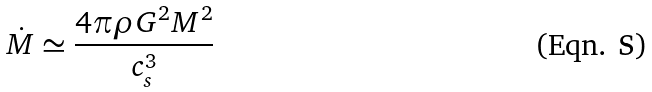Convert formula to latex. <formula><loc_0><loc_0><loc_500><loc_500>\dot { M } \simeq \frac { 4 \pi \rho G ^ { 2 } M ^ { 2 } } { c _ { s } ^ { 3 } }</formula> 